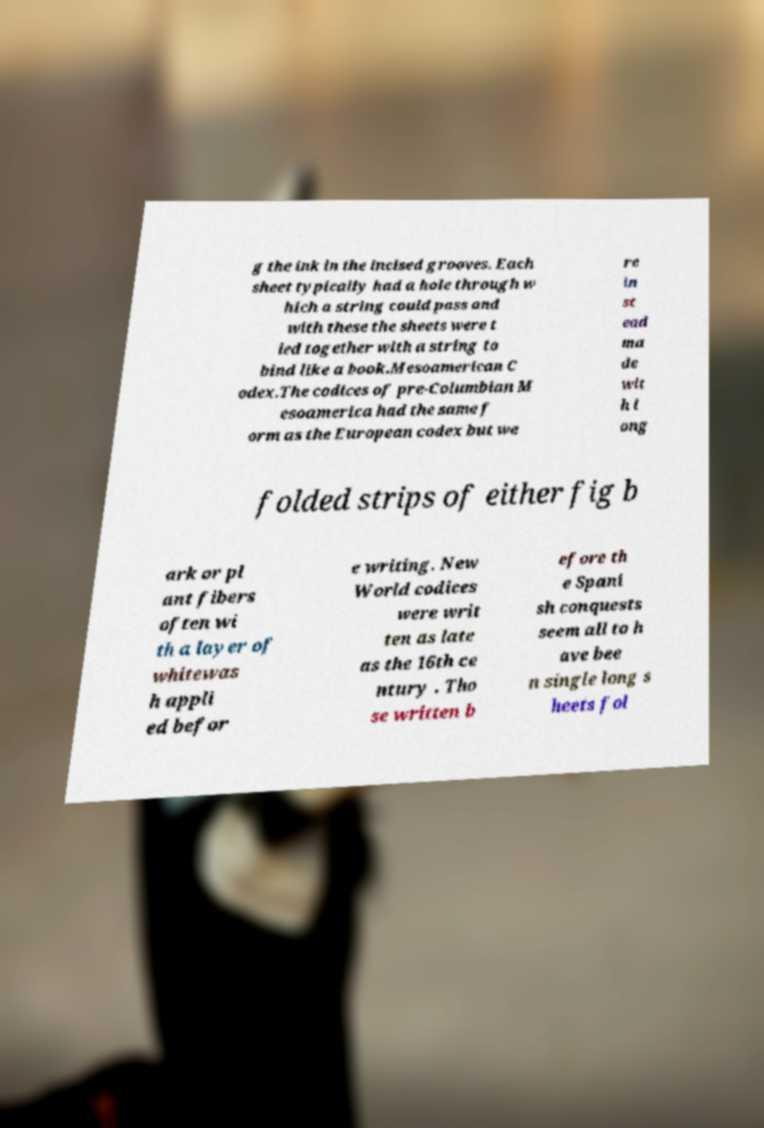For documentation purposes, I need the text within this image transcribed. Could you provide that? g the ink in the incised grooves. Each sheet typically had a hole through w hich a string could pass and with these the sheets were t ied together with a string to bind like a book.Mesoamerican C odex.The codices of pre-Columbian M esoamerica had the same f orm as the European codex but we re in st ead ma de wit h l ong folded strips of either fig b ark or pl ant fibers often wi th a layer of whitewas h appli ed befor e writing. New World codices were writ ten as late as the 16th ce ntury . Tho se written b efore th e Spani sh conquests seem all to h ave bee n single long s heets fol 